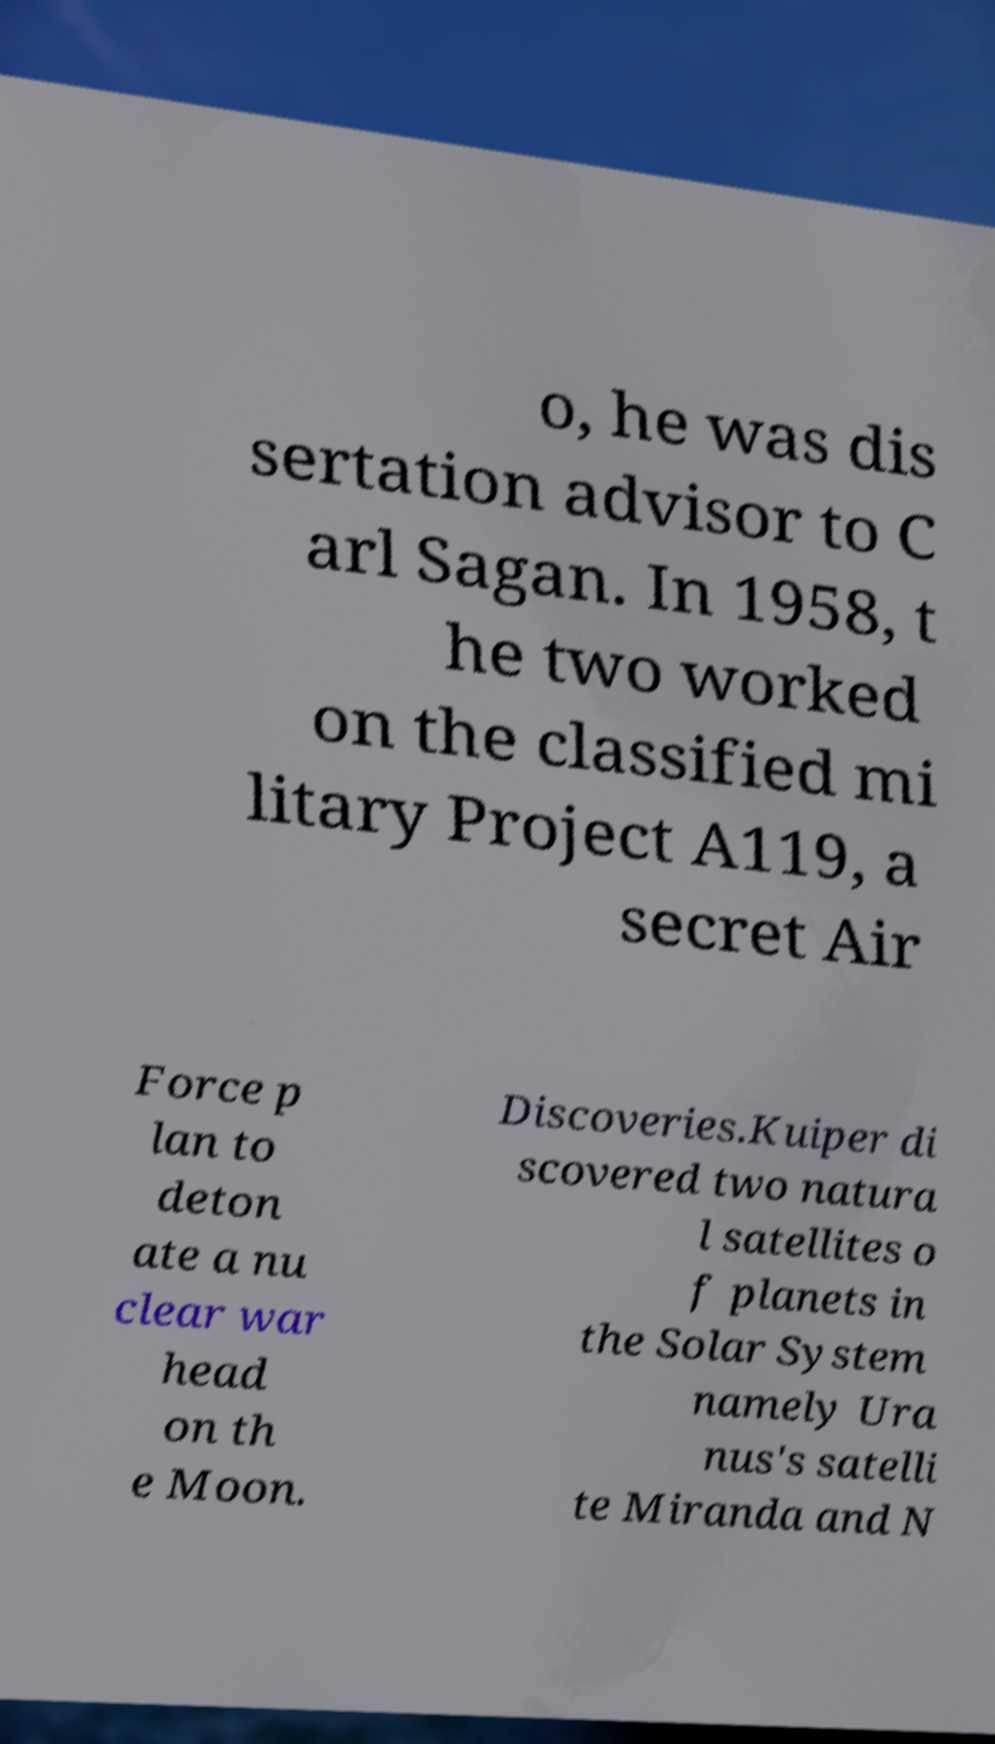Could you assist in decoding the text presented in this image and type it out clearly? o, he was dis sertation advisor to C arl Sagan. In 1958, t he two worked on the classified mi litary Project A119, a secret Air Force p lan to deton ate a nu clear war head on th e Moon. Discoveries.Kuiper di scovered two natura l satellites o f planets in the Solar System namely Ura nus's satelli te Miranda and N 